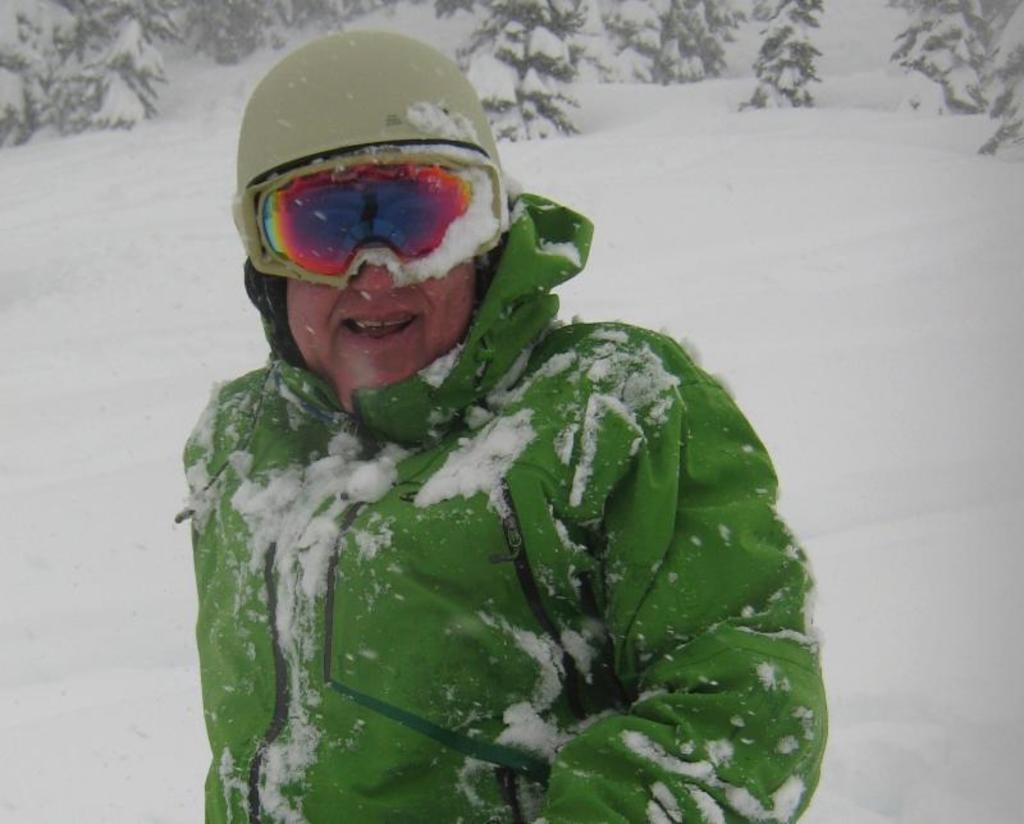What is the person in the image standing on? The person is standing on the snow. What color is the coat the person is wearing? The person is wearing a green coat. What type of eyewear is the person wearing? The person is wearing glasses. What type of headgear is the person wearing? The person is wearing a helmet. What type of weather condition is depicted in the image? There is snow visible in the image, indicating a cold or wintry condition. What can be seen in the background of the image? Trees are present at the back of the image. What type of ornament is hanging from the person's neck in the image? There is no ornament hanging from the person's neck in the image. What role does the actor play in the scene depicted in the image? There is no actor or scene depicted in the image; it is a photograph of a person standing on snow. 